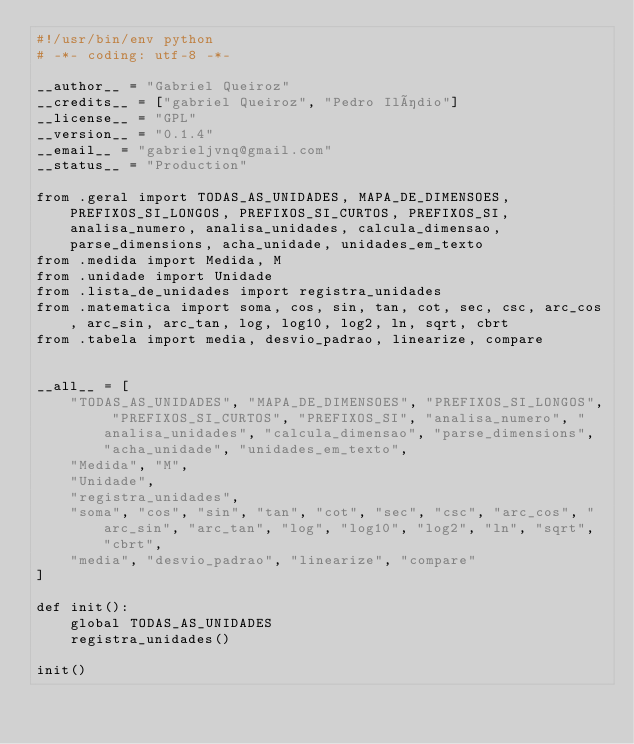<code> <loc_0><loc_0><loc_500><loc_500><_Python_>#!/usr/bin/env python
# -*- coding: utf-8 -*-

__author__ = "Gabriel Queiroz"
__credits__ = ["gabriel Queiroz", "Pedro Ilídio"]
__license__ = "GPL"
__version__ = "0.1.4"
__email__ = "gabrieljvnq@gmail.com"
__status__ = "Production"

from .geral import TODAS_AS_UNIDADES, MAPA_DE_DIMENSOES, PREFIXOS_SI_LONGOS, PREFIXOS_SI_CURTOS, PREFIXOS_SI, analisa_numero, analisa_unidades, calcula_dimensao, parse_dimensions, acha_unidade, unidades_em_texto
from .medida import Medida, M
from .unidade import Unidade
from .lista_de_unidades import registra_unidades
from .matematica import soma, cos, sin, tan, cot, sec, csc, arc_cos, arc_sin, arc_tan, log, log10, log2, ln, sqrt, cbrt
from .tabela import media, desvio_padrao, linearize, compare


__all__ = [
    "TODAS_AS_UNIDADES", "MAPA_DE_DIMENSOES", "PREFIXOS_SI_LONGOS", "PREFIXOS_SI_CURTOS", "PREFIXOS_SI", "analisa_numero", "analisa_unidades", "calcula_dimensao", "parse_dimensions", "acha_unidade", "unidades_em_texto",
    "Medida", "M",
    "Unidade",
    "registra_unidades",
    "soma", "cos", "sin", "tan", "cot", "sec", "csc", "arc_cos", "arc_sin", "arc_tan", "log", "log10", "log2", "ln", "sqrt", "cbrt",
    "media", "desvio_padrao", "linearize", "compare"
]

def init():
    global TODAS_AS_UNIDADES
    registra_unidades()

init()
</code> 